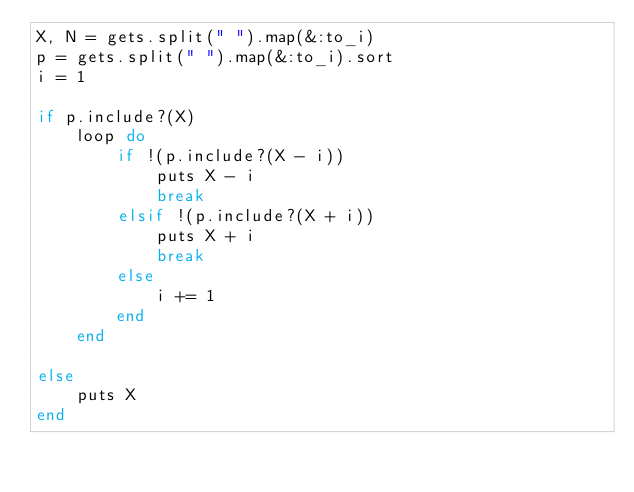<code> <loc_0><loc_0><loc_500><loc_500><_Ruby_>X, N = gets.split(" ").map(&:to_i)
p = gets.split(" ").map(&:to_i).sort
i = 1

if p.include?(X) 
    loop do
        if !(p.include?(X - i))
            puts X - i
            break
        elsif !(p.include?(X + i))
            puts X + i
            break
        else
            i += 1
        end
    end

else
    puts X
end</code> 